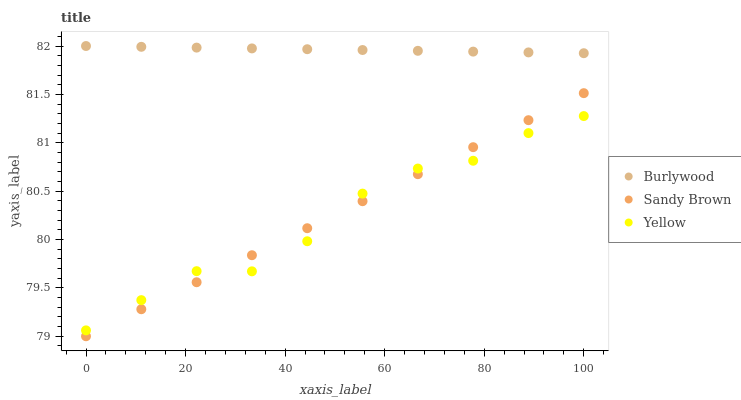Does Yellow have the minimum area under the curve?
Answer yes or no. Yes. Does Burlywood have the maximum area under the curve?
Answer yes or no. Yes. Does Sandy Brown have the minimum area under the curve?
Answer yes or no. No. Does Sandy Brown have the maximum area under the curve?
Answer yes or no. No. Is Burlywood the smoothest?
Answer yes or no. Yes. Is Yellow the roughest?
Answer yes or no. Yes. Is Sandy Brown the smoothest?
Answer yes or no. No. Is Sandy Brown the roughest?
Answer yes or no. No. Does Sandy Brown have the lowest value?
Answer yes or no. Yes. Does Yellow have the lowest value?
Answer yes or no. No. Does Burlywood have the highest value?
Answer yes or no. Yes. Does Sandy Brown have the highest value?
Answer yes or no. No. Is Sandy Brown less than Burlywood?
Answer yes or no. Yes. Is Burlywood greater than Yellow?
Answer yes or no. Yes. Does Yellow intersect Sandy Brown?
Answer yes or no. Yes. Is Yellow less than Sandy Brown?
Answer yes or no. No. Is Yellow greater than Sandy Brown?
Answer yes or no. No. Does Sandy Brown intersect Burlywood?
Answer yes or no. No. 